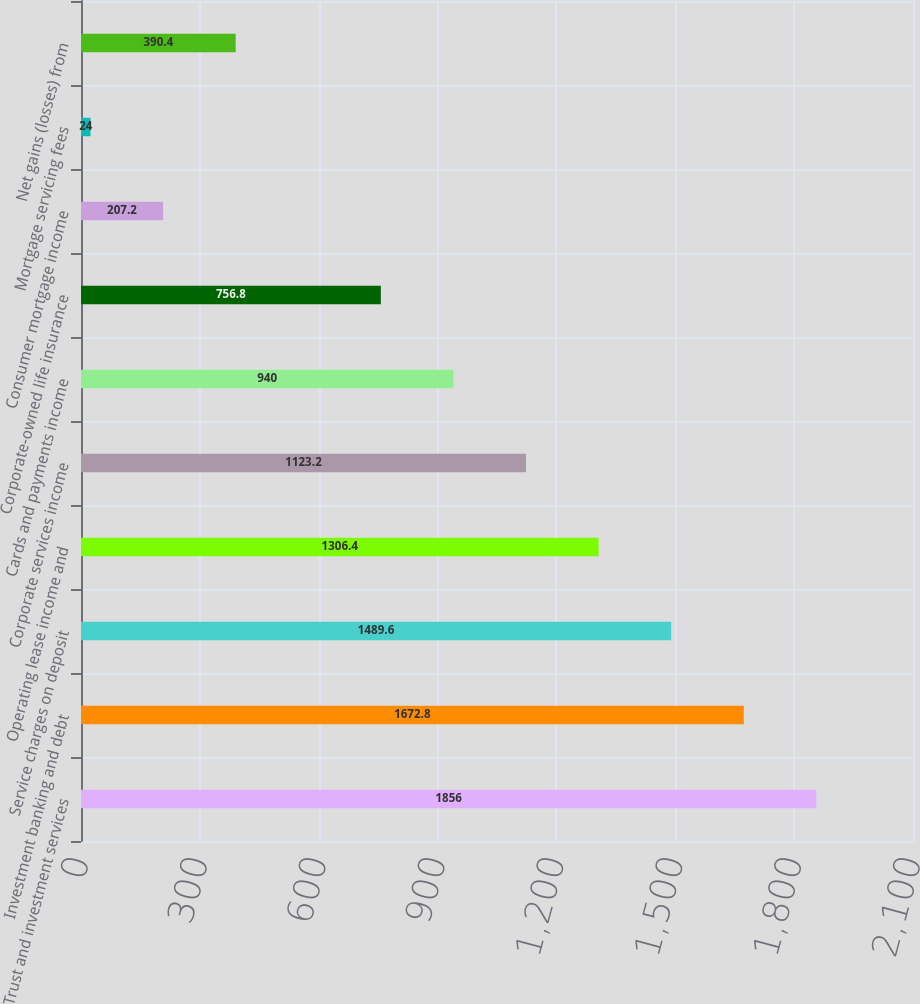Convert chart to OTSL. <chart><loc_0><loc_0><loc_500><loc_500><bar_chart><fcel>Trust and investment services<fcel>Investment banking and debt<fcel>Service charges on deposit<fcel>Operating lease income and<fcel>Corporate services income<fcel>Cards and payments income<fcel>Corporate-owned life insurance<fcel>Consumer mortgage income<fcel>Mortgage servicing fees<fcel>Net gains (losses) from<nl><fcel>1856<fcel>1672.8<fcel>1489.6<fcel>1306.4<fcel>1123.2<fcel>940<fcel>756.8<fcel>207.2<fcel>24<fcel>390.4<nl></chart> 